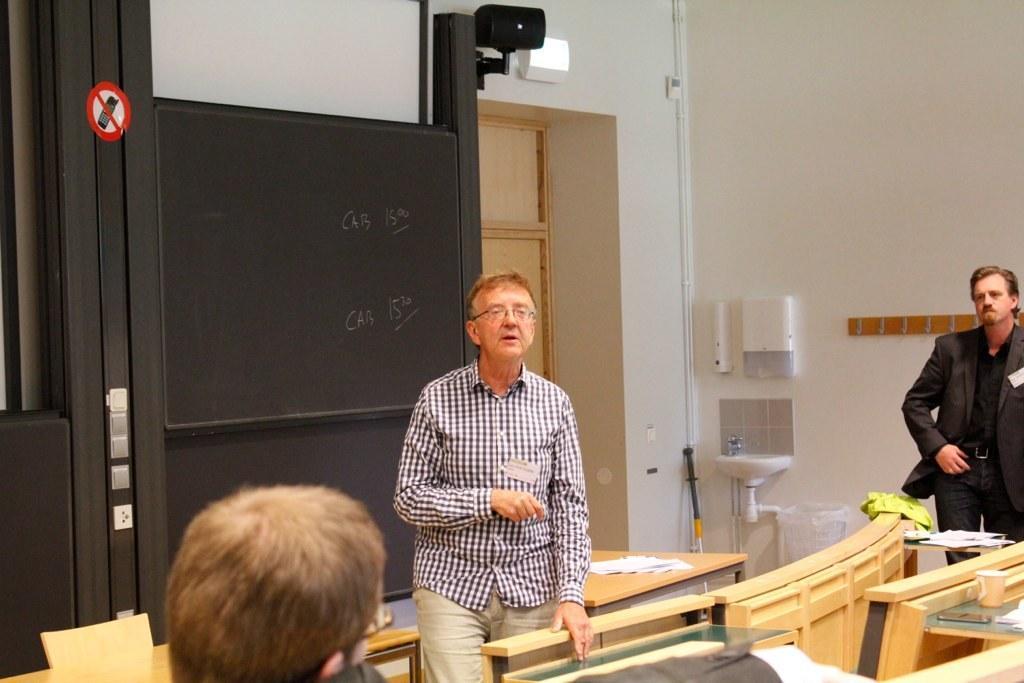Describe this image in one or two sentences. there are 3 people in this image. the person at the right corner is wearing the suit. the person at the center is standing. behind them there is a black board and a door 